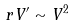<formula> <loc_0><loc_0><loc_500><loc_500>r { V ^ { \prime } } \sim V ^ { 2 }</formula> 